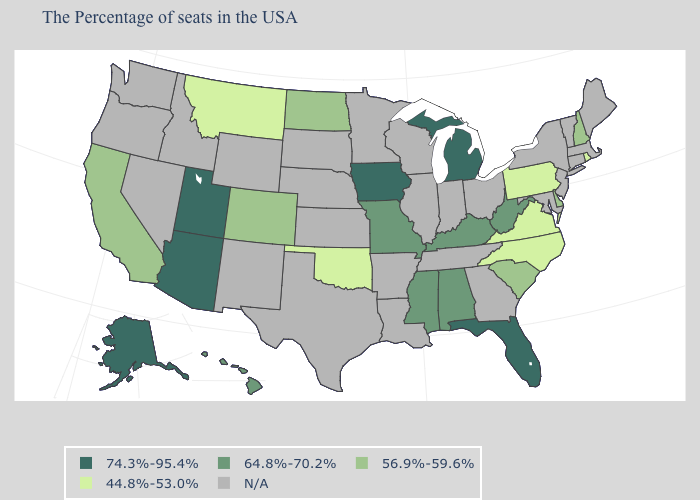Does Arizona have the highest value in the West?
Concise answer only. Yes. What is the value of Kansas?
Give a very brief answer. N/A. Among the states that border Wyoming , which have the lowest value?
Concise answer only. Montana. Name the states that have a value in the range N/A?
Write a very short answer. Maine, Massachusetts, Vermont, Connecticut, New York, New Jersey, Maryland, Ohio, Georgia, Indiana, Tennessee, Wisconsin, Illinois, Louisiana, Arkansas, Minnesota, Kansas, Nebraska, Texas, South Dakota, Wyoming, New Mexico, Idaho, Nevada, Washington, Oregon. Does the map have missing data?
Give a very brief answer. Yes. Among the states that border North Carolina , which have the lowest value?
Short answer required. Virginia. Does Rhode Island have the lowest value in the Northeast?
Keep it brief. Yes. Does Alaska have the lowest value in the USA?
Quick response, please. No. Does Montana have the lowest value in the USA?
Give a very brief answer. Yes. What is the value of Illinois?
Answer briefly. N/A. Name the states that have a value in the range 56.9%-59.6%?
Be succinct. New Hampshire, Delaware, South Carolina, North Dakota, Colorado, California. Which states hav the highest value in the Northeast?
Give a very brief answer. New Hampshire. What is the highest value in the South ?
Write a very short answer. 74.3%-95.4%. Name the states that have a value in the range 44.8%-53.0%?
Short answer required. Rhode Island, Pennsylvania, Virginia, North Carolina, Oklahoma, Montana. 